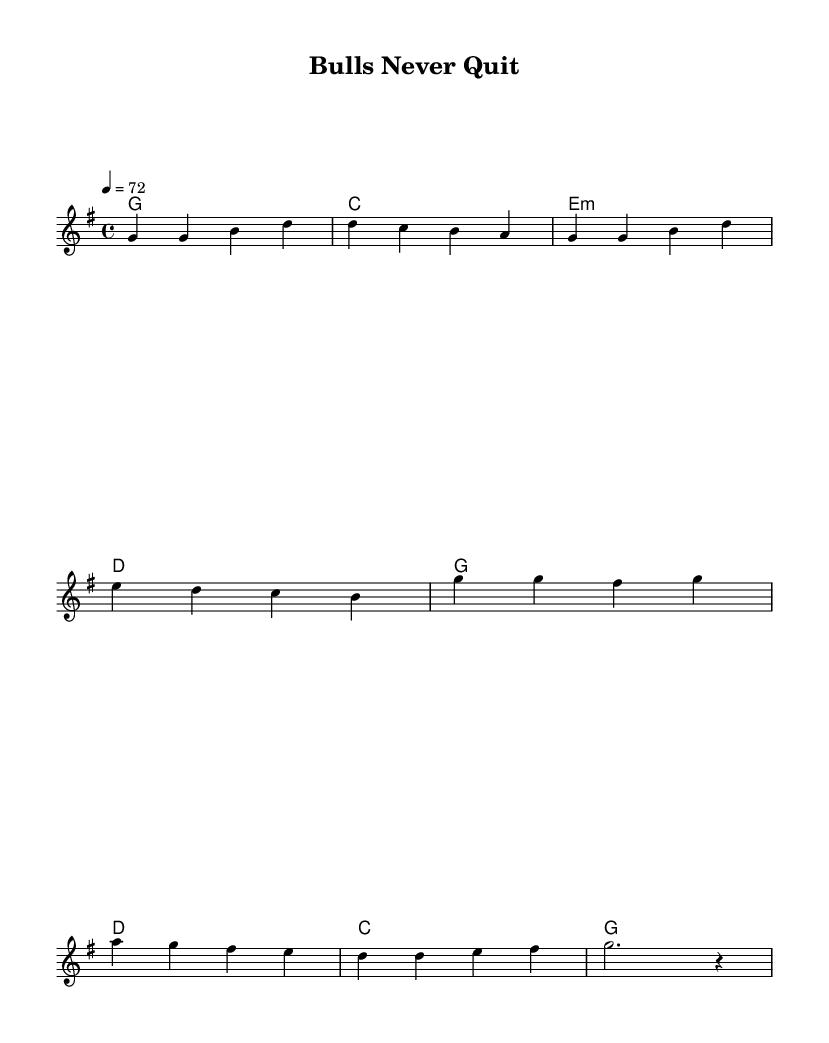What is the key signature of this music? The key signature is G major, which has one sharp (F#). This is indicated at the beginning of the sheet music, where the key signature appears.
Answer: G major What is the time signature of this music? The time signature is 4/4, which means there are four beats in each measure and the quarter note gets one beat. This can be found at the beginning of the music notation.
Answer: 4/4 What is the tempo marking of this music? The tempo marking is 4 = 72, which indicates that there are 72 beats per minute, and each beat corresponds to a quarter note. This is noted in the tempo indication section of the score.
Answer: 72 How many measures are in the verse? The verse consists of four measures, as evidenced by the four groups of notes shown for the verse melody on the staff. Each group represents a measure.
Answer: Four What is the main theme of the chorus? The main theme of the chorus is perseverance, as expressed through the lyrics that emphasize standing tall and strong through challenges. This can be inferred from the words written above the notes in the chorus section.
Answer: Perseverance What chords accompany the verse? The chords accompanying the verse are G, C, E minor, and D. These are indicated in the chord mode section aligned with the melody of the verse.
Answer: G, C, E minor, D What lyrical message is repeated in the chorus? The message of never giving up is repeated in the chorus, stated clearly in the lyrics. The chorus emphasizes endurance and resilience through adversity, which resonates as the core message.
Answer: Never give up 